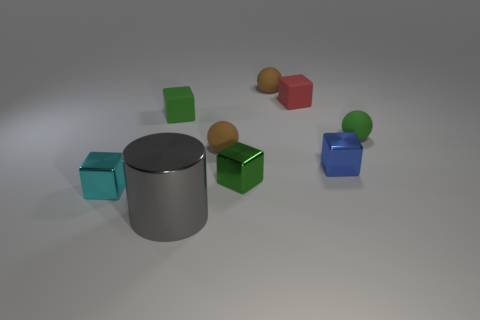Add 1 large green cylinders. How many objects exist? 10 Subtract all small green rubber balls. How many balls are left? 2 Subtract 2 green cubes. How many objects are left? 7 Subtract all cylinders. How many objects are left? 8 Subtract 2 blocks. How many blocks are left? 3 Subtract all yellow blocks. Subtract all cyan cylinders. How many blocks are left? 5 Subtract all cyan cylinders. How many green balls are left? 1 Subtract all blue objects. Subtract all small brown things. How many objects are left? 6 Add 7 small green balls. How many small green balls are left? 8 Add 5 blue objects. How many blue objects exist? 6 